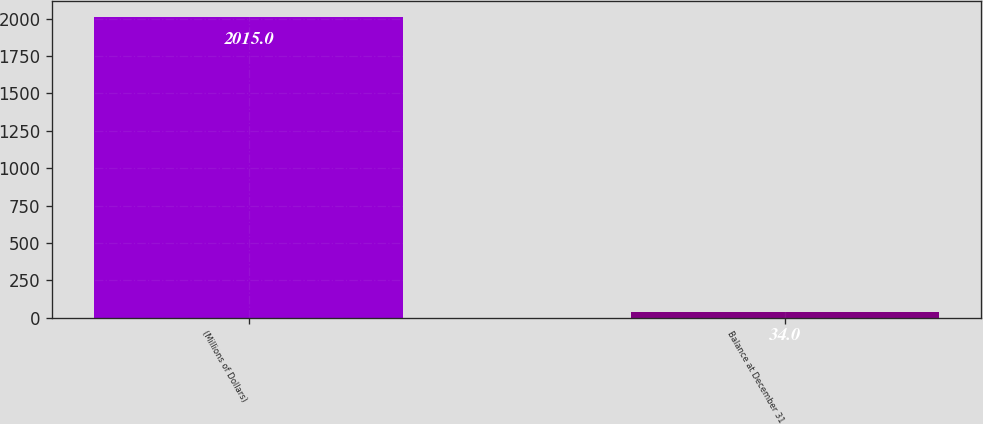<chart> <loc_0><loc_0><loc_500><loc_500><bar_chart><fcel>(Millions of Dollars)<fcel>Balance at December 31<nl><fcel>2015<fcel>34<nl></chart> 